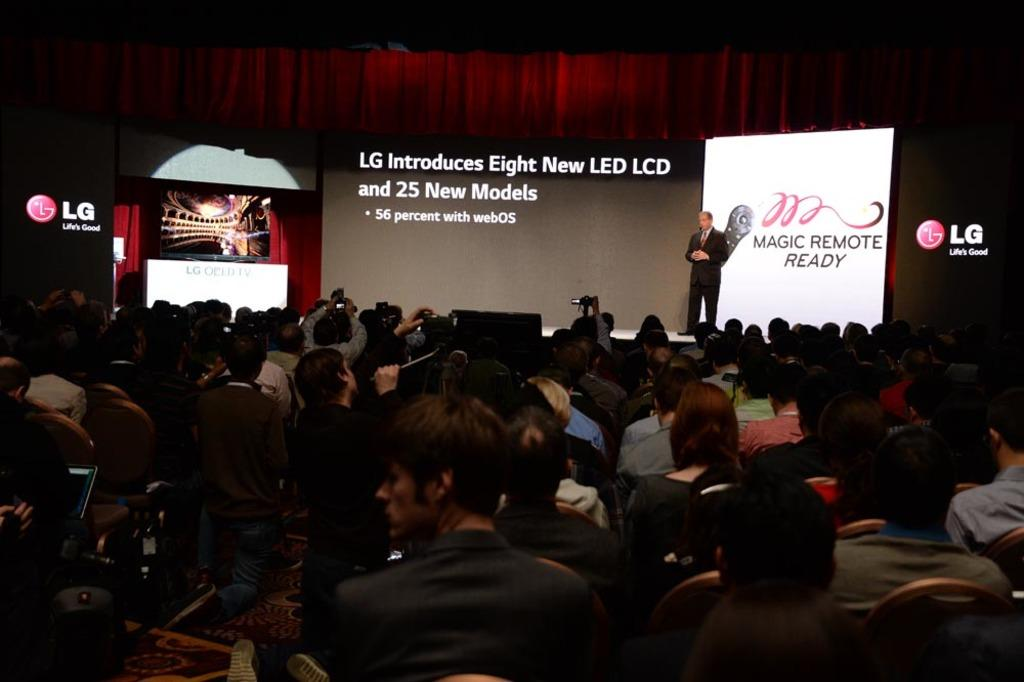What is happening in the foreground of the image? There are people sitting in the foreground of the image. What can be seen on the right side of the image? There is a person on the stage on the right side of the image. What is visible in the background of the image? There are posters and a curtain in the background of the image. How many pies are being served on the stage in the image? There are no pies visible in the image; the person on the stage is the main focus. What type of screw is being used to hold the curtain in the background? There is no mention of a screw in the image; the curtain is simply hanging in the background. 